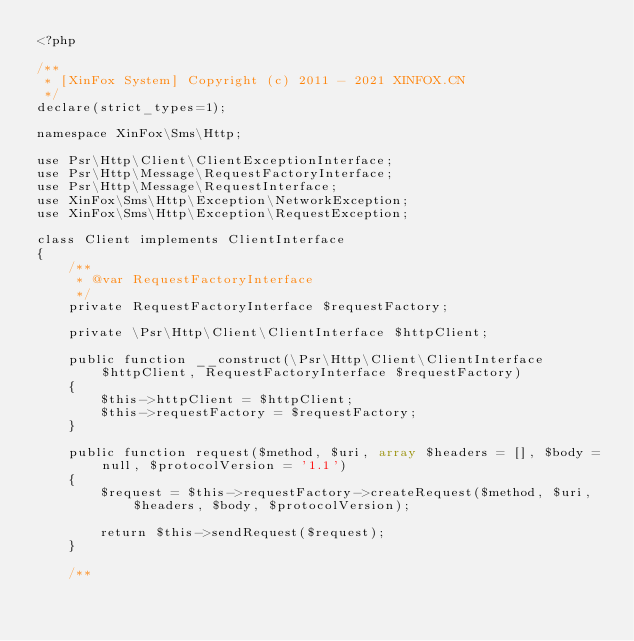Convert code to text. <code><loc_0><loc_0><loc_500><loc_500><_PHP_><?php

/**
 * [XinFox System] Copyright (c) 2011 - 2021 XINFOX.CN
 */
declare(strict_types=1);

namespace XinFox\Sms\Http;

use Psr\Http\Client\ClientExceptionInterface;
use Psr\Http\Message\RequestFactoryInterface;
use Psr\Http\Message\RequestInterface;
use XinFox\Sms\Http\Exception\NetworkException;
use XinFox\Sms\Http\Exception\RequestException;

class Client implements ClientInterface
{
    /**
     * @var RequestFactoryInterface
     */
    private RequestFactoryInterface $requestFactory;

    private \Psr\Http\Client\ClientInterface $httpClient;

    public function __construct(\Psr\Http\Client\ClientInterface $httpClient, RequestFactoryInterface $requestFactory)
    {
        $this->httpClient = $httpClient;
        $this->requestFactory = $requestFactory;
    }

    public function request($method, $uri, array $headers = [], $body = null, $protocolVersion = '1.1')
    {
        $request = $this->requestFactory->createRequest($method, $uri, $headers, $body, $protocolVersion);

        return $this->sendRequest($request);
    }

    /**</code> 